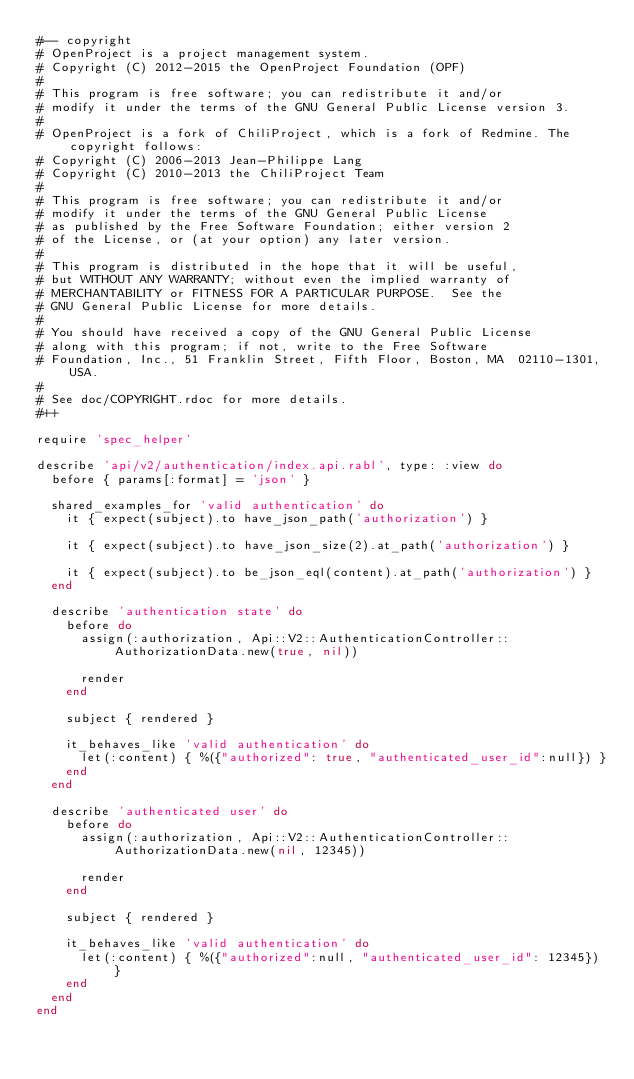<code> <loc_0><loc_0><loc_500><loc_500><_Ruby_>#-- copyright
# OpenProject is a project management system.
# Copyright (C) 2012-2015 the OpenProject Foundation (OPF)
#
# This program is free software; you can redistribute it and/or
# modify it under the terms of the GNU General Public License version 3.
#
# OpenProject is a fork of ChiliProject, which is a fork of Redmine. The copyright follows:
# Copyright (C) 2006-2013 Jean-Philippe Lang
# Copyright (C) 2010-2013 the ChiliProject Team
#
# This program is free software; you can redistribute it and/or
# modify it under the terms of the GNU General Public License
# as published by the Free Software Foundation; either version 2
# of the License, or (at your option) any later version.
#
# This program is distributed in the hope that it will be useful,
# but WITHOUT ANY WARRANTY; without even the implied warranty of
# MERCHANTABILITY or FITNESS FOR A PARTICULAR PURPOSE.  See the
# GNU General Public License for more details.
#
# You should have received a copy of the GNU General Public License
# along with this program; if not, write to the Free Software
# Foundation, Inc., 51 Franklin Street, Fifth Floor, Boston, MA  02110-1301, USA.
#
# See doc/COPYRIGHT.rdoc for more details.
#++

require 'spec_helper'

describe 'api/v2/authentication/index.api.rabl', type: :view do
  before { params[:format] = 'json' }

  shared_examples_for 'valid authentication' do
    it { expect(subject).to have_json_path('authorization') }

    it { expect(subject).to have_json_size(2).at_path('authorization') }

    it { expect(subject).to be_json_eql(content).at_path('authorization') }
  end

  describe 'authentication state' do
    before do
      assign(:authorization, Api::V2::AuthenticationController::AuthorizationData.new(true, nil))

      render
    end

    subject { rendered }

    it_behaves_like 'valid authentication' do
      let(:content) { %({"authorized": true, "authenticated_user_id":null}) }
    end
  end

  describe 'authenticated user' do
    before do
      assign(:authorization, Api::V2::AuthenticationController::AuthorizationData.new(nil, 12345))

      render
    end

    subject { rendered }

    it_behaves_like 'valid authentication' do
      let(:content) { %({"authorized":null, "authenticated_user_id": 12345}) }
    end
  end
end
</code> 